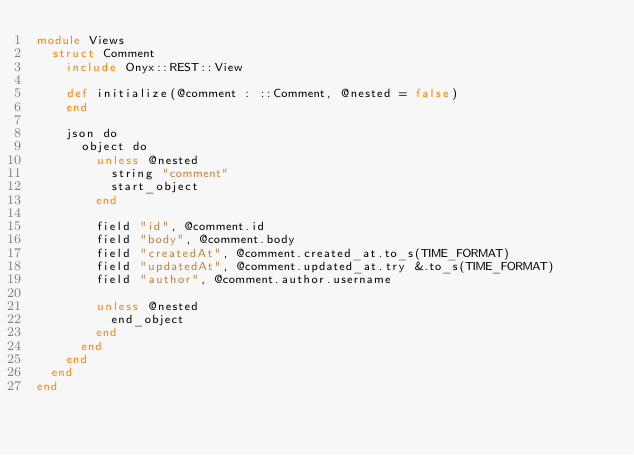<code> <loc_0><loc_0><loc_500><loc_500><_Crystal_>module Views
  struct Comment
    include Onyx::REST::View

    def initialize(@comment : ::Comment, @nested = false)
    end

    json do
      object do
        unless @nested
          string "comment"
          start_object
        end

        field "id", @comment.id
        field "body", @comment.body
        field "createdAt", @comment.created_at.to_s(TIME_FORMAT)
        field "updatedAt", @comment.updated_at.try &.to_s(TIME_FORMAT)
        field "author", @comment.author.username

        unless @nested
          end_object
        end
      end
    end
  end
end
</code> 